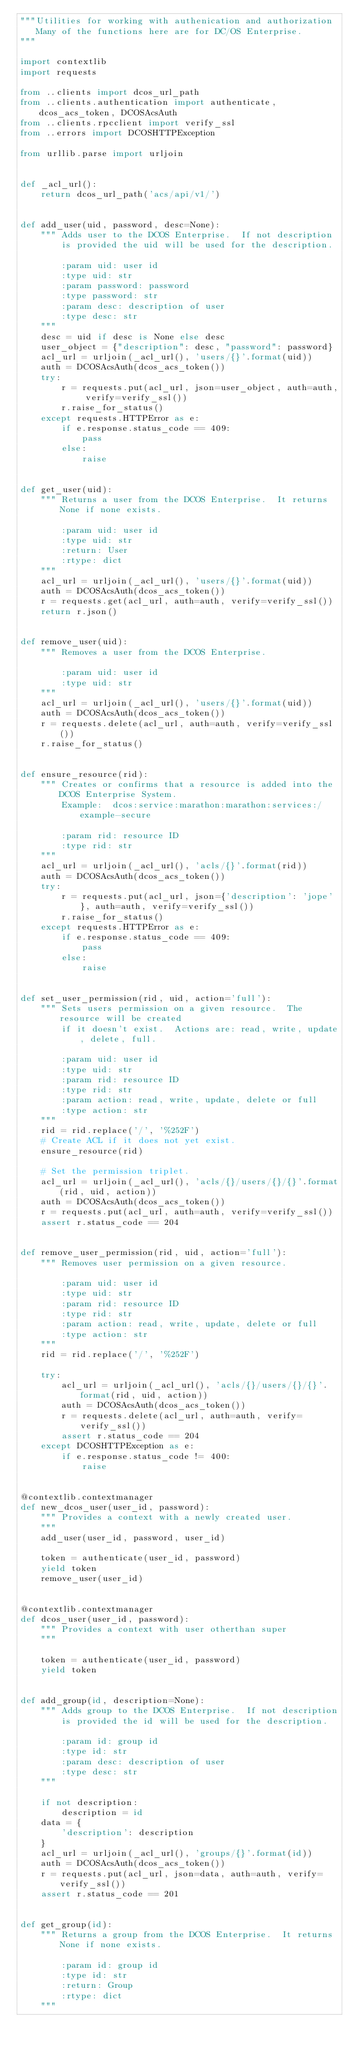Convert code to text. <code><loc_0><loc_0><loc_500><loc_500><_Python_>"""Utilities for working with authenication and authorization
   Many of the functions here are for DC/OS Enterprise.
"""

import contextlib
import requests

from ..clients import dcos_url_path
from ..clients.authentication import authenticate, dcos_acs_token, DCOSAcsAuth
from ..clients.rpcclient import verify_ssl
from ..errors import DCOSHTTPException

from urllib.parse import urljoin


def _acl_url():
    return dcos_url_path('acs/api/v1/')


def add_user(uid, password, desc=None):
    """ Adds user to the DCOS Enterprise.  If not description
        is provided the uid will be used for the description.

        :param uid: user id
        :type uid: str
        :param password: password
        :type password: str
        :param desc: description of user
        :type desc: str
    """
    desc = uid if desc is None else desc
    user_object = {"description": desc, "password": password}
    acl_url = urljoin(_acl_url(), 'users/{}'.format(uid))
    auth = DCOSAcsAuth(dcos_acs_token())
    try:
        r = requests.put(acl_url, json=user_object, auth=auth, verify=verify_ssl())
        r.raise_for_status()
    except requests.HTTPError as e:
        if e.response.status_code == 409:
            pass
        else:
            raise


def get_user(uid):
    """ Returns a user from the DCOS Enterprise.  It returns None if none exists.

        :param uid: user id
        :type uid: str
        :return: User
        :rtype: dict
    """
    acl_url = urljoin(_acl_url(), 'users/{}'.format(uid))
    auth = DCOSAcsAuth(dcos_acs_token())
    r = requests.get(acl_url, auth=auth, verify=verify_ssl())
    return r.json()


def remove_user(uid):
    """ Removes a user from the DCOS Enterprise.

        :param uid: user id
        :type uid: str
    """
    acl_url = urljoin(_acl_url(), 'users/{}'.format(uid))
    auth = DCOSAcsAuth(dcos_acs_token())
    r = requests.delete(acl_url, auth=auth, verify=verify_ssl())
    r.raise_for_status()


def ensure_resource(rid):
    """ Creates or confirms that a resource is added into the DCOS Enterprise System.
        Example:  dcos:service:marathon:marathon:services:/example-secure

        :param rid: resource ID
        :type rid: str
    """
    acl_url = urljoin(_acl_url(), 'acls/{}'.format(rid))
    auth = DCOSAcsAuth(dcos_acs_token())
    try:
        r = requests.put(acl_url, json={'description': 'jope'}, auth=auth, verify=verify_ssl())
        r.raise_for_status()
    except requests.HTTPError as e:
        if e.response.status_code == 409:
            pass
        else:
            raise


def set_user_permission(rid, uid, action='full'):
    """ Sets users permission on a given resource.  The resource will be created
        if it doesn't exist.  Actions are: read, write, update, delete, full.

        :param uid: user id
        :type uid: str
        :param rid: resource ID
        :type rid: str
        :param action: read, write, update, delete or full
        :type action: str
    """
    rid = rid.replace('/', '%252F')
    # Create ACL if it does not yet exist.
    ensure_resource(rid)

    # Set the permission triplet.
    acl_url = urljoin(_acl_url(), 'acls/{}/users/{}/{}'.format(rid, uid, action))
    auth = DCOSAcsAuth(dcos_acs_token())
    r = requests.put(acl_url, auth=auth, verify=verify_ssl())
    assert r.status_code == 204


def remove_user_permission(rid, uid, action='full'):
    """ Removes user permission on a given resource.

        :param uid: user id
        :type uid: str
        :param rid: resource ID
        :type rid: str
        :param action: read, write, update, delete or full
        :type action: str
    """
    rid = rid.replace('/', '%252F')

    try:
        acl_url = urljoin(_acl_url(), 'acls/{}/users/{}/{}'.format(rid, uid, action))
        auth = DCOSAcsAuth(dcos_acs_token())
        r = requests.delete(acl_url, auth=auth, verify=verify_ssl())
        assert r.status_code == 204
    except DCOSHTTPException as e:
        if e.response.status_code != 400:
            raise


@contextlib.contextmanager
def new_dcos_user(user_id, password):
    """ Provides a context with a newly created user.
    """
    add_user(user_id, password, user_id)

    token = authenticate(user_id, password)
    yield token
    remove_user(user_id)


@contextlib.contextmanager
def dcos_user(user_id, password):
    """ Provides a context with user otherthan super
    """

    token = authenticate(user_id, password)
    yield token


def add_group(id, description=None):
    """ Adds group to the DCOS Enterprise.  If not description
        is provided the id will be used for the description.

        :param id: group id
        :type id: str
        :param desc: description of user
        :type desc: str
    """

    if not description:
        description = id
    data = {
        'description': description
    }
    acl_url = urljoin(_acl_url(), 'groups/{}'.format(id))
    auth = DCOSAcsAuth(dcos_acs_token())
    r = requests.put(acl_url, json=data, auth=auth, verify=verify_ssl())
    assert r.status_code == 201


def get_group(id):
    """ Returns a group from the DCOS Enterprise.  It returns None if none exists.

        :param id: group id
        :type id: str
        :return: Group
        :rtype: dict
    """</code> 